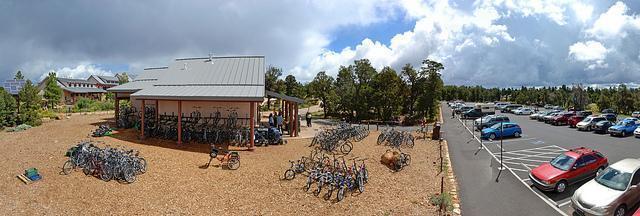How many cars are visible?
Give a very brief answer. 2. 